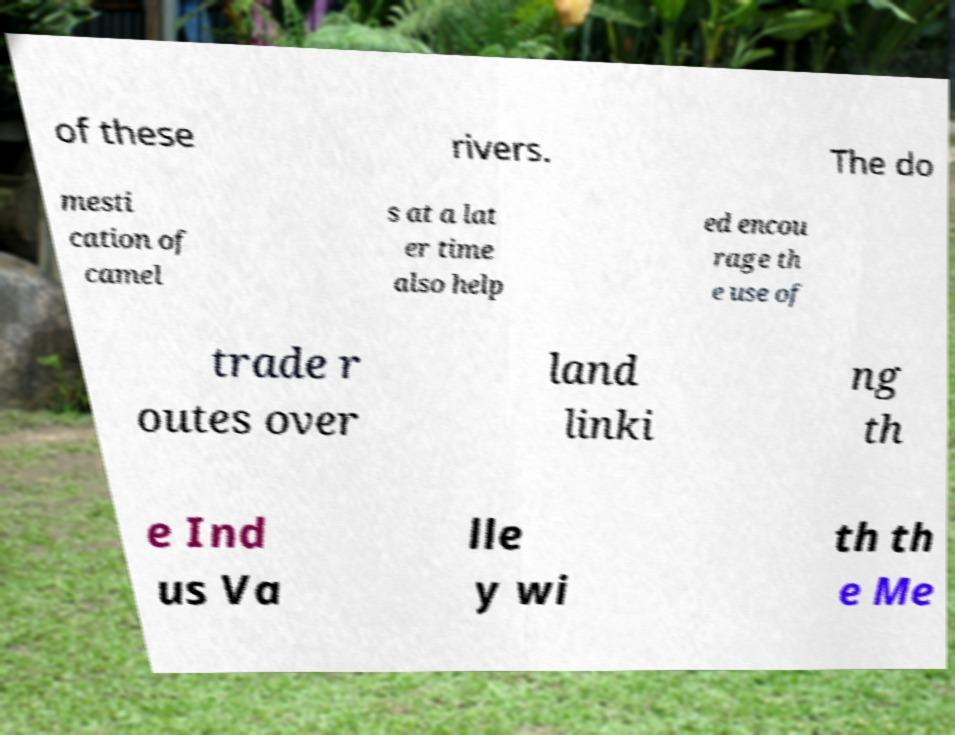There's text embedded in this image that I need extracted. Can you transcribe it verbatim? of these rivers. The do mesti cation of camel s at a lat er time also help ed encou rage th e use of trade r outes over land linki ng th e Ind us Va lle y wi th th e Me 